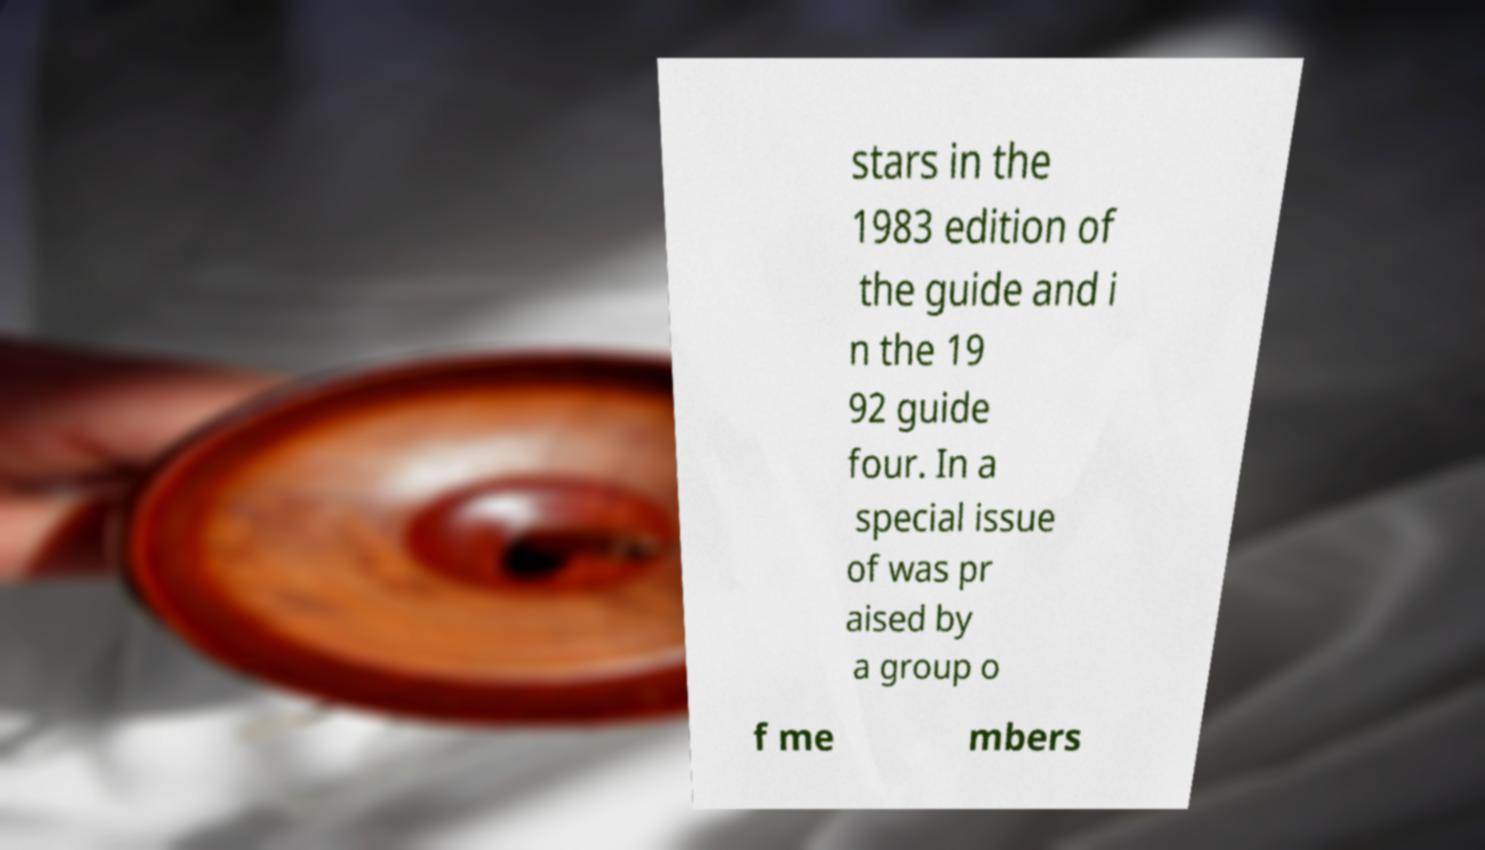Can you accurately transcribe the text from the provided image for me? stars in the 1983 edition of the guide and i n the 19 92 guide four. In a special issue of was pr aised by a group o f me mbers 